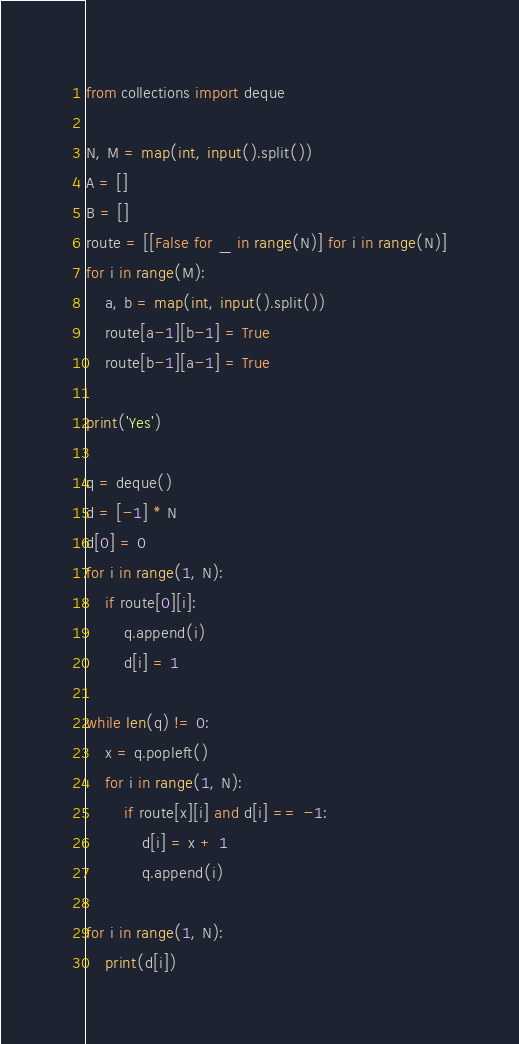<code> <loc_0><loc_0><loc_500><loc_500><_Python_>from collections import deque

N, M = map(int, input().split())
A = []
B = []
route = [[False for _ in range(N)] for i in range(N)]
for i in range(M):
    a, b = map(int, input().split())
    route[a-1][b-1] = True
    route[b-1][a-1] = True

print('Yes')

q = deque()
d = [-1] * N
d[0] = 0
for i in range(1, N):
    if route[0][i]:
        q.append(i)
        d[i] = 1

while len(q) != 0:
    x = q.popleft()
    for i in range(1, N):
        if route[x][i] and d[i] == -1:
            d[i] = x + 1
            q.append(i)

for i in range(1, N):
    print(d[i])
</code> 